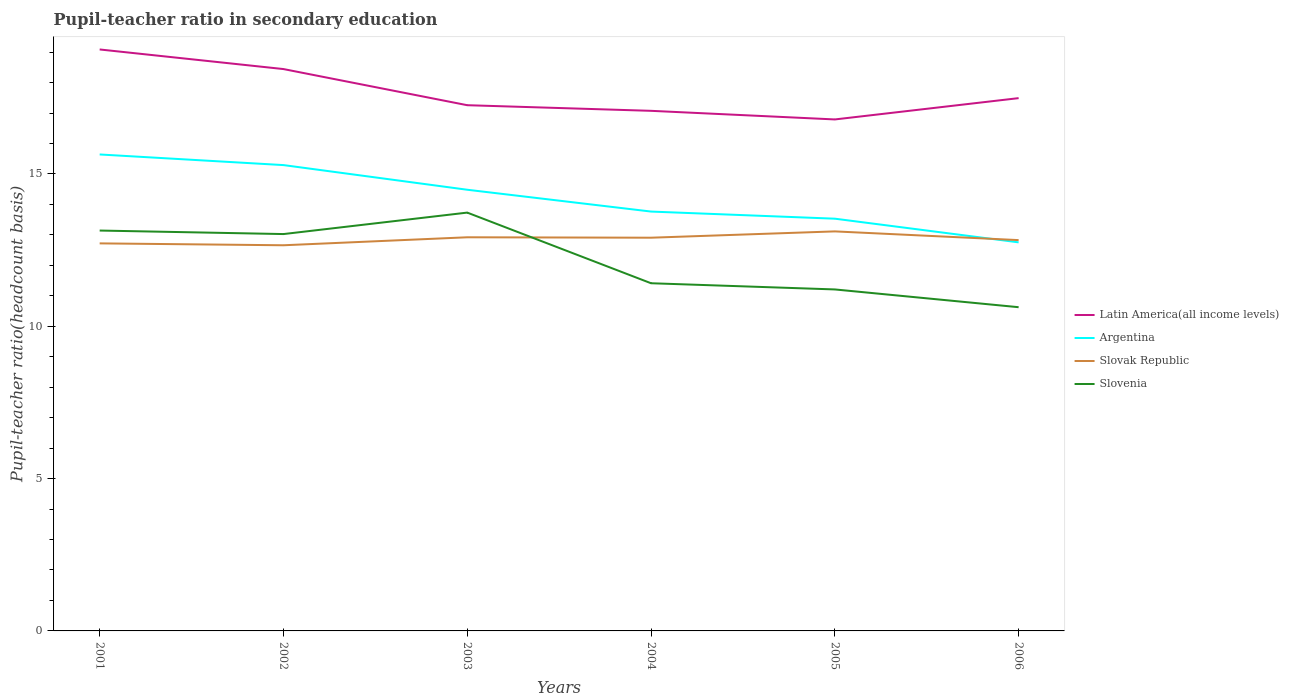Across all years, what is the maximum pupil-teacher ratio in secondary education in Argentina?
Your response must be concise. 12.76. What is the total pupil-teacher ratio in secondary education in Slovak Republic in the graph?
Keep it short and to the point. -0.26. What is the difference between the highest and the second highest pupil-teacher ratio in secondary education in Slovenia?
Provide a succinct answer. 3.11. Is the pupil-teacher ratio in secondary education in Argentina strictly greater than the pupil-teacher ratio in secondary education in Slovak Republic over the years?
Your answer should be compact. No. How many years are there in the graph?
Provide a succinct answer. 6. What is the difference between two consecutive major ticks on the Y-axis?
Offer a very short reply. 5. Does the graph contain grids?
Your response must be concise. No. How many legend labels are there?
Give a very brief answer. 4. What is the title of the graph?
Give a very brief answer. Pupil-teacher ratio in secondary education. Does "Poland" appear as one of the legend labels in the graph?
Ensure brevity in your answer.  No. What is the label or title of the Y-axis?
Ensure brevity in your answer.  Pupil-teacher ratio(headcount basis). What is the Pupil-teacher ratio(headcount basis) in Latin America(all income levels) in 2001?
Your answer should be very brief. 19.09. What is the Pupil-teacher ratio(headcount basis) in Argentina in 2001?
Your answer should be very brief. 15.64. What is the Pupil-teacher ratio(headcount basis) of Slovak Republic in 2001?
Make the answer very short. 12.72. What is the Pupil-teacher ratio(headcount basis) of Slovenia in 2001?
Ensure brevity in your answer.  13.14. What is the Pupil-teacher ratio(headcount basis) of Latin America(all income levels) in 2002?
Provide a short and direct response. 18.44. What is the Pupil-teacher ratio(headcount basis) of Argentina in 2002?
Ensure brevity in your answer.  15.29. What is the Pupil-teacher ratio(headcount basis) in Slovak Republic in 2002?
Keep it short and to the point. 12.66. What is the Pupil-teacher ratio(headcount basis) of Slovenia in 2002?
Offer a terse response. 13.03. What is the Pupil-teacher ratio(headcount basis) in Latin America(all income levels) in 2003?
Your response must be concise. 17.26. What is the Pupil-teacher ratio(headcount basis) in Argentina in 2003?
Your answer should be compact. 14.48. What is the Pupil-teacher ratio(headcount basis) in Slovak Republic in 2003?
Provide a short and direct response. 12.92. What is the Pupil-teacher ratio(headcount basis) of Slovenia in 2003?
Your answer should be compact. 13.73. What is the Pupil-teacher ratio(headcount basis) in Latin America(all income levels) in 2004?
Provide a succinct answer. 17.07. What is the Pupil-teacher ratio(headcount basis) of Argentina in 2004?
Your answer should be compact. 13.77. What is the Pupil-teacher ratio(headcount basis) in Slovak Republic in 2004?
Offer a very short reply. 12.91. What is the Pupil-teacher ratio(headcount basis) of Slovenia in 2004?
Offer a very short reply. 11.41. What is the Pupil-teacher ratio(headcount basis) in Latin America(all income levels) in 2005?
Make the answer very short. 16.79. What is the Pupil-teacher ratio(headcount basis) in Argentina in 2005?
Your answer should be very brief. 13.53. What is the Pupil-teacher ratio(headcount basis) of Slovak Republic in 2005?
Provide a short and direct response. 13.12. What is the Pupil-teacher ratio(headcount basis) of Slovenia in 2005?
Your answer should be compact. 11.21. What is the Pupil-teacher ratio(headcount basis) of Latin America(all income levels) in 2006?
Give a very brief answer. 17.49. What is the Pupil-teacher ratio(headcount basis) in Argentina in 2006?
Provide a short and direct response. 12.76. What is the Pupil-teacher ratio(headcount basis) in Slovak Republic in 2006?
Ensure brevity in your answer.  12.83. What is the Pupil-teacher ratio(headcount basis) of Slovenia in 2006?
Ensure brevity in your answer.  10.63. Across all years, what is the maximum Pupil-teacher ratio(headcount basis) in Latin America(all income levels)?
Your answer should be compact. 19.09. Across all years, what is the maximum Pupil-teacher ratio(headcount basis) in Argentina?
Provide a short and direct response. 15.64. Across all years, what is the maximum Pupil-teacher ratio(headcount basis) in Slovak Republic?
Your response must be concise. 13.12. Across all years, what is the maximum Pupil-teacher ratio(headcount basis) in Slovenia?
Your answer should be compact. 13.73. Across all years, what is the minimum Pupil-teacher ratio(headcount basis) in Latin America(all income levels)?
Your response must be concise. 16.79. Across all years, what is the minimum Pupil-teacher ratio(headcount basis) of Argentina?
Offer a terse response. 12.76. Across all years, what is the minimum Pupil-teacher ratio(headcount basis) in Slovak Republic?
Your answer should be compact. 12.66. Across all years, what is the minimum Pupil-teacher ratio(headcount basis) in Slovenia?
Ensure brevity in your answer.  10.63. What is the total Pupil-teacher ratio(headcount basis) in Latin America(all income levels) in the graph?
Provide a short and direct response. 106.14. What is the total Pupil-teacher ratio(headcount basis) in Argentina in the graph?
Ensure brevity in your answer.  85.47. What is the total Pupil-teacher ratio(headcount basis) in Slovak Republic in the graph?
Give a very brief answer. 77.16. What is the total Pupil-teacher ratio(headcount basis) of Slovenia in the graph?
Make the answer very short. 73.15. What is the difference between the Pupil-teacher ratio(headcount basis) in Latin America(all income levels) in 2001 and that in 2002?
Your answer should be compact. 0.64. What is the difference between the Pupil-teacher ratio(headcount basis) of Argentina in 2001 and that in 2002?
Provide a succinct answer. 0.35. What is the difference between the Pupil-teacher ratio(headcount basis) in Slovak Republic in 2001 and that in 2002?
Offer a very short reply. 0.06. What is the difference between the Pupil-teacher ratio(headcount basis) in Slovenia in 2001 and that in 2002?
Offer a terse response. 0.12. What is the difference between the Pupil-teacher ratio(headcount basis) of Latin America(all income levels) in 2001 and that in 2003?
Keep it short and to the point. 1.83. What is the difference between the Pupil-teacher ratio(headcount basis) of Argentina in 2001 and that in 2003?
Keep it short and to the point. 1.16. What is the difference between the Pupil-teacher ratio(headcount basis) of Slovak Republic in 2001 and that in 2003?
Ensure brevity in your answer.  -0.2. What is the difference between the Pupil-teacher ratio(headcount basis) of Slovenia in 2001 and that in 2003?
Offer a very short reply. -0.59. What is the difference between the Pupil-teacher ratio(headcount basis) of Latin America(all income levels) in 2001 and that in 2004?
Provide a succinct answer. 2.01. What is the difference between the Pupil-teacher ratio(headcount basis) of Argentina in 2001 and that in 2004?
Provide a short and direct response. 1.87. What is the difference between the Pupil-teacher ratio(headcount basis) in Slovak Republic in 2001 and that in 2004?
Provide a succinct answer. -0.19. What is the difference between the Pupil-teacher ratio(headcount basis) of Slovenia in 2001 and that in 2004?
Offer a terse response. 1.73. What is the difference between the Pupil-teacher ratio(headcount basis) in Latin America(all income levels) in 2001 and that in 2005?
Your answer should be very brief. 2.3. What is the difference between the Pupil-teacher ratio(headcount basis) of Argentina in 2001 and that in 2005?
Provide a succinct answer. 2.11. What is the difference between the Pupil-teacher ratio(headcount basis) in Slovak Republic in 2001 and that in 2005?
Your answer should be very brief. -0.39. What is the difference between the Pupil-teacher ratio(headcount basis) of Slovenia in 2001 and that in 2005?
Your answer should be compact. 1.93. What is the difference between the Pupil-teacher ratio(headcount basis) in Latin America(all income levels) in 2001 and that in 2006?
Provide a succinct answer. 1.6. What is the difference between the Pupil-teacher ratio(headcount basis) of Argentina in 2001 and that in 2006?
Provide a short and direct response. 2.88. What is the difference between the Pupil-teacher ratio(headcount basis) in Slovak Republic in 2001 and that in 2006?
Your response must be concise. -0.11. What is the difference between the Pupil-teacher ratio(headcount basis) in Slovenia in 2001 and that in 2006?
Provide a short and direct response. 2.52. What is the difference between the Pupil-teacher ratio(headcount basis) of Latin America(all income levels) in 2002 and that in 2003?
Provide a succinct answer. 1.19. What is the difference between the Pupil-teacher ratio(headcount basis) in Argentina in 2002 and that in 2003?
Offer a terse response. 0.81. What is the difference between the Pupil-teacher ratio(headcount basis) of Slovak Republic in 2002 and that in 2003?
Your response must be concise. -0.26. What is the difference between the Pupil-teacher ratio(headcount basis) in Slovenia in 2002 and that in 2003?
Provide a succinct answer. -0.7. What is the difference between the Pupil-teacher ratio(headcount basis) of Latin America(all income levels) in 2002 and that in 2004?
Your answer should be very brief. 1.37. What is the difference between the Pupil-teacher ratio(headcount basis) of Argentina in 2002 and that in 2004?
Your answer should be compact. 1.53. What is the difference between the Pupil-teacher ratio(headcount basis) of Slovak Republic in 2002 and that in 2004?
Provide a succinct answer. -0.25. What is the difference between the Pupil-teacher ratio(headcount basis) in Slovenia in 2002 and that in 2004?
Provide a short and direct response. 1.61. What is the difference between the Pupil-teacher ratio(headcount basis) of Latin America(all income levels) in 2002 and that in 2005?
Provide a succinct answer. 1.65. What is the difference between the Pupil-teacher ratio(headcount basis) in Argentina in 2002 and that in 2005?
Ensure brevity in your answer.  1.76. What is the difference between the Pupil-teacher ratio(headcount basis) of Slovak Republic in 2002 and that in 2005?
Offer a very short reply. -0.46. What is the difference between the Pupil-teacher ratio(headcount basis) in Slovenia in 2002 and that in 2005?
Provide a short and direct response. 1.82. What is the difference between the Pupil-teacher ratio(headcount basis) in Latin America(all income levels) in 2002 and that in 2006?
Your answer should be compact. 0.95. What is the difference between the Pupil-teacher ratio(headcount basis) in Argentina in 2002 and that in 2006?
Your response must be concise. 2.54. What is the difference between the Pupil-teacher ratio(headcount basis) in Slovak Republic in 2002 and that in 2006?
Offer a terse response. -0.17. What is the difference between the Pupil-teacher ratio(headcount basis) in Slovenia in 2002 and that in 2006?
Your answer should be very brief. 2.4. What is the difference between the Pupil-teacher ratio(headcount basis) of Latin America(all income levels) in 2003 and that in 2004?
Offer a very short reply. 0.18. What is the difference between the Pupil-teacher ratio(headcount basis) in Argentina in 2003 and that in 2004?
Make the answer very short. 0.72. What is the difference between the Pupil-teacher ratio(headcount basis) of Slovak Republic in 2003 and that in 2004?
Your answer should be compact. 0.01. What is the difference between the Pupil-teacher ratio(headcount basis) of Slovenia in 2003 and that in 2004?
Provide a short and direct response. 2.32. What is the difference between the Pupil-teacher ratio(headcount basis) of Latin America(all income levels) in 2003 and that in 2005?
Your answer should be compact. 0.47. What is the difference between the Pupil-teacher ratio(headcount basis) of Argentina in 2003 and that in 2005?
Keep it short and to the point. 0.95. What is the difference between the Pupil-teacher ratio(headcount basis) of Slovak Republic in 2003 and that in 2005?
Your answer should be very brief. -0.19. What is the difference between the Pupil-teacher ratio(headcount basis) of Slovenia in 2003 and that in 2005?
Ensure brevity in your answer.  2.52. What is the difference between the Pupil-teacher ratio(headcount basis) in Latin America(all income levels) in 2003 and that in 2006?
Keep it short and to the point. -0.23. What is the difference between the Pupil-teacher ratio(headcount basis) in Argentina in 2003 and that in 2006?
Make the answer very short. 1.73. What is the difference between the Pupil-teacher ratio(headcount basis) of Slovak Republic in 2003 and that in 2006?
Make the answer very short. 0.09. What is the difference between the Pupil-teacher ratio(headcount basis) in Slovenia in 2003 and that in 2006?
Offer a very short reply. 3.11. What is the difference between the Pupil-teacher ratio(headcount basis) of Latin America(all income levels) in 2004 and that in 2005?
Provide a succinct answer. 0.28. What is the difference between the Pupil-teacher ratio(headcount basis) of Argentina in 2004 and that in 2005?
Your response must be concise. 0.23. What is the difference between the Pupil-teacher ratio(headcount basis) in Slovak Republic in 2004 and that in 2005?
Ensure brevity in your answer.  -0.21. What is the difference between the Pupil-teacher ratio(headcount basis) in Slovenia in 2004 and that in 2005?
Your response must be concise. 0.2. What is the difference between the Pupil-teacher ratio(headcount basis) of Latin America(all income levels) in 2004 and that in 2006?
Keep it short and to the point. -0.42. What is the difference between the Pupil-teacher ratio(headcount basis) of Argentina in 2004 and that in 2006?
Offer a terse response. 1.01. What is the difference between the Pupil-teacher ratio(headcount basis) of Slovak Republic in 2004 and that in 2006?
Provide a short and direct response. 0.08. What is the difference between the Pupil-teacher ratio(headcount basis) in Slovenia in 2004 and that in 2006?
Your response must be concise. 0.79. What is the difference between the Pupil-teacher ratio(headcount basis) of Latin America(all income levels) in 2005 and that in 2006?
Provide a short and direct response. -0.7. What is the difference between the Pupil-teacher ratio(headcount basis) in Argentina in 2005 and that in 2006?
Give a very brief answer. 0.78. What is the difference between the Pupil-teacher ratio(headcount basis) in Slovak Republic in 2005 and that in 2006?
Provide a short and direct response. 0.29. What is the difference between the Pupil-teacher ratio(headcount basis) of Slovenia in 2005 and that in 2006?
Give a very brief answer. 0.58. What is the difference between the Pupil-teacher ratio(headcount basis) of Latin America(all income levels) in 2001 and the Pupil-teacher ratio(headcount basis) of Argentina in 2002?
Keep it short and to the point. 3.8. What is the difference between the Pupil-teacher ratio(headcount basis) of Latin America(all income levels) in 2001 and the Pupil-teacher ratio(headcount basis) of Slovak Republic in 2002?
Offer a very short reply. 6.43. What is the difference between the Pupil-teacher ratio(headcount basis) of Latin America(all income levels) in 2001 and the Pupil-teacher ratio(headcount basis) of Slovenia in 2002?
Keep it short and to the point. 6.06. What is the difference between the Pupil-teacher ratio(headcount basis) of Argentina in 2001 and the Pupil-teacher ratio(headcount basis) of Slovak Republic in 2002?
Your answer should be compact. 2.98. What is the difference between the Pupil-teacher ratio(headcount basis) of Argentina in 2001 and the Pupil-teacher ratio(headcount basis) of Slovenia in 2002?
Offer a very short reply. 2.61. What is the difference between the Pupil-teacher ratio(headcount basis) in Slovak Republic in 2001 and the Pupil-teacher ratio(headcount basis) in Slovenia in 2002?
Keep it short and to the point. -0.31. What is the difference between the Pupil-teacher ratio(headcount basis) in Latin America(all income levels) in 2001 and the Pupil-teacher ratio(headcount basis) in Argentina in 2003?
Provide a short and direct response. 4.6. What is the difference between the Pupil-teacher ratio(headcount basis) of Latin America(all income levels) in 2001 and the Pupil-teacher ratio(headcount basis) of Slovak Republic in 2003?
Your answer should be very brief. 6.17. What is the difference between the Pupil-teacher ratio(headcount basis) in Latin America(all income levels) in 2001 and the Pupil-teacher ratio(headcount basis) in Slovenia in 2003?
Give a very brief answer. 5.36. What is the difference between the Pupil-teacher ratio(headcount basis) in Argentina in 2001 and the Pupil-teacher ratio(headcount basis) in Slovak Republic in 2003?
Ensure brevity in your answer.  2.72. What is the difference between the Pupil-teacher ratio(headcount basis) of Argentina in 2001 and the Pupil-teacher ratio(headcount basis) of Slovenia in 2003?
Give a very brief answer. 1.91. What is the difference between the Pupil-teacher ratio(headcount basis) of Slovak Republic in 2001 and the Pupil-teacher ratio(headcount basis) of Slovenia in 2003?
Give a very brief answer. -1.01. What is the difference between the Pupil-teacher ratio(headcount basis) in Latin America(all income levels) in 2001 and the Pupil-teacher ratio(headcount basis) in Argentina in 2004?
Your answer should be compact. 5.32. What is the difference between the Pupil-teacher ratio(headcount basis) in Latin America(all income levels) in 2001 and the Pupil-teacher ratio(headcount basis) in Slovak Republic in 2004?
Ensure brevity in your answer.  6.18. What is the difference between the Pupil-teacher ratio(headcount basis) of Latin America(all income levels) in 2001 and the Pupil-teacher ratio(headcount basis) of Slovenia in 2004?
Keep it short and to the point. 7.67. What is the difference between the Pupil-teacher ratio(headcount basis) of Argentina in 2001 and the Pupil-teacher ratio(headcount basis) of Slovak Republic in 2004?
Make the answer very short. 2.73. What is the difference between the Pupil-teacher ratio(headcount basis) of Argentina in 2001 and the Pupil-teacher ratio(headcount basis) of Slovenia in 2004?
Make the answer very short. 4.23. What is the difference between the Pupil-teacher ratio(headcount basis) in Slovak Republic in 2001 and the Pupil-teacher ratio(headcount basis) in Slovenia in 2004?
Ensure brevity in your answer.  1.31. What is the difference between the Pupil-teacher ratio(headcount basis) of Latin America(all income levels) in 2001 and the Pupil-teacher ratio(headcount basis) of Argentina in 2005?
Provide a succinct answer. 5.55. What is the difference between the Pupil-teacher ratio(headcount basis) of Latin America(all income levels) in 2001 and the Pupil-teacher ratio(headcount basis) of Slovak Republic in 2005?
Provide a short and direct response. 5.97. What is the difference between the Pupil-teacher ratio(headcount basis) of Latin America(all income levels) in 2001 and the Pupil-teacher ratio(headcount basis) of Slovenia in 2005?
Keep it short and to the point. 7.88. What is the difference between the Pupil-teacher ratio(headcount basis) in Argentina in 2001 and the Pupil-teacher ratio(headcount basis) in Slovak Republic in 2005?
Your answer should be compact. 2.53. What is the difference between the Pupil-teacher ratio(headcount basis) in Argentina in 2001 and the Pupil-teacher ratio(headcount basis) in Slovenia in 2005?
Keep it short and to the point. 4.43. What is the difference between the Pupil-teacher ratio(headcount basis) of Slovak Republic in 2001 and the Pupil-teacher ratio(headcount basis) of Slovenia in 2005?
Provide a short and direct response. 1.51. What is the difference between the Pupil-teacher ratio(headcount basis) of Latin America(all income levels) in 2001 and the Pupil-teacher ratio(headcount basis) of Argentina in 2006?
Your answer should be compact. 6.33. What is the difference between the Pupil-teacher ratio(headcount basis) in Latin America(all income levels) in 2001 and the Pupil-teacher ratio(headcount basis) in Slovak Republic in 2006?
Make the answer very short. 6.26. What is the difference between the Pupil-teacher ratio(headcount basis) of Latin America(all income levels) in 2001 and the Pupil-teacher ratio(headcount basis) of Slovenia in 2006?
Your response must be concise. 8.46. What is the difference between the Pupil-teacher ratio(headcount basis) in Argentina in 2001 and the Pupil-teacher ratio(headcount basis) in Slovak Republic in 2006?
Provide a short and direct response. 2.81. What is the difference between the Pupil-teacher ratio(headcount basis) of Argentina in 2001 and the Pupil-teacher ratio(headcount basis) of Slovenia in 2006?
Offer a very short reply. 5.01. What is the difference between the Pupil-teacher ratio(headcount basis) of Slovak Republic in 2001 and the Pupil-teacher ratio(headcount basis) of Slovenia in 2006?
Ensure brevity in your answer.  2.1. What is the difference between the Pupil-teacher ratio(headcount basis) in Latin America(all income levels) in 2002 and the Pupil-teacher ratio(headcount basis) in Argentina in 2003?
Your response must be concise. 3.96. What is the difference between the Pupil-teacher ratio(headcount basis) of Latin America(all income levels) in 2002 and the Pupil-teacher ratio(headcount basis) of Slovak Republic in 2003?
Offer a terse response. 5.52. What is the difference between the Pupil-teacher ratio(headcount basis) in Latin America(all income levels) in 2002 and the Pupil-teacher ratio(headcount basis) in Slovenia in 2003?
Your answer should be very brief. 4.71. What is the difference between the Pupil-teacher ratio(headcount basis) of Argentina in 2002 and the Pupil-teacher ratio(headcount basis) of Slovak Republic in 2003?
Ensure brevity in your answer.  2.37. What is the difference between the Pupil-teacher ratio(headcount basis) of Argentina in 2002 and the Pupil-teacher ratio(headcount basis) of Slovenia in 2003?
Make the answer very short. 1.56. What is the difference between the Pupil-teacher ratio(headcount basis) of Slovak Republic in 2002 and the Pupil-teacher ratio(headcount basis) of Slovenia in 2003?
Provide a succinct answer. -1.07. What is the difference between the Pupil-teacher ratio(headcount basis) of Latin America(all income levels) in 2002 and the Pupil-teacher ratio(headcount basis) of Argentina in 2004?
Your answer should be compact. 4.68. What is the difference between the Pupil-teacher ratio(headcount basis) in Latin America(all income levels) in 2002 and the Pupil-teacher ratio(headcount basis) in Slovak Republic in 2004?
Provide a short and direct response. 5.54. What is the difference between the Pupil-teacher ratio(headcount basis) in Latin America(all income levels) in 2002 and the Pupil-teacher ratio(headcount basis) in Slovenia in 2004?
Provide a short and direct response. 7.03. What is the difference between the Pupil-teacher ratio(headcount basis) in Argentina in 2002 and the Pupil-teacher ratio(headcount basis) in Slovak Republic in 2004?
Provide a succinct answer. 2.38. What is the difference between the Pupil-teacher ratio(headcount basis) of Argentina in 2002 and the Pupil-teacher ratio(headcount basis) of Slovenia in 2004?
Make the answer very short. 3.88. What is the difference between the Pupil-teacher ratio(headcount basis) of Slovak Republic in 2002 and the Pupil-teacher ratio(headcount basis) of Slovenia in 2004?
Provide a succinct answer. 1.25. What is the difference between the Pupil-teacher ratio(headcount basis) of Latin America(all income levels) in 2002 and the Pupil-teacher ratio(headcount basis) of Argentina in 2005?
Your response must be concise. 4.91. What is the difference between the Pupil-teacher ratio(headcount basis) of Latin America(all income levels) in 2002 and the Pupil-teacher ratio(headcount basis) of Slovak Republic in 2005?
Your answer should be compact. 5.33. What is the difference between the Pupil-teacher ratio(headcount basis) in Latin America(all income levels) in 2002 and the Pupil-teacher ratio(headcount basis) in Slovenia in 2005?
Your response must be concise. 7.23. What is the difference between the Pupil-teacher ratio(headcount basis) of Argentina in 2002 and the Pupil-teacher ratio(headcount basis) of Slovak Republic in 2005?
Your response must be concise. 2.18. What is the difference between the Pupil-teacher ratio(headcount basis) in Argentina in 2002 and the Pupil-teacher ratio(headcount basis) in Slovenia in 2005?
Offer a terse response. 4.08. What is the difference between the Pupil-teacher ratio(headcount basis) in Slovak Republic in 2002 and the Pupil-teacher ratio(headcount basis) in Slovenia in 2005?
Make the answer very short. 1.45. What is the difference between the Pupil-teacher ratio(headcount basis) in Latin America(all income levels) in 2002 and the Pupil-teacher ratio(headcount basis) in Argentina in 2006?
Provide a succinct answer. 5.69. What is the difference between the Pupil-teacher ratio(headcount basis) in Latin America(all income levels) in 2002 and the Pupil-teacher ratio(headcount basis) in Slovak Republic in 2006?
Keep it short and to the point. 5.62. What is the difference between the Pupil-teacher ratio(headcount basis) of Latin America(all income levels) in 2002 and the Pupil-teacher ratio(headcount basis) of Slovenia in 2006?
Keep it short and to the point. 7.82. What is the difference between the Pupil-teacher ratio(headcount basis) of Argentina in 2002 and the Pupil-teacher ratio(headcount basis) of Slovak Republic in 2006?
Your response must be concise. 2.46. What is the difference between the Pupil-teacher ratio(headcount basis) of Argentina in 2002 and the Pupil-teacher ratio(headcount basis) of Slovenia in 2006?
Offer a very short reply. 4.67. What is the difference between the Pupil-teacher ratio(headcount basis) of Slovak Republic in 2002 and the Pupil-teacher ratio(headcount basis) of Slovenia in 2006?
Provide a short and direct response. 2.03. What is the difference between the Pupil-teacher ratio(headcount basis) in Latin America(all income levels) in 2003 and the Pupil-teacher ratio(headcount basis) in Argentina in 2004?
Provide a succinct answer. 3.49. What is the difference between the Pupil-teacher ratio(headcount basis) of Latin America(all income levels) in 2003 and the Pupil-teacher ratio(headcount basis) of Slovak Republic in 2004?
Your answer should be compact. 4.35. What is the difference between the Pupil-teacher ratio(headcount basis) of Latin America(all income levels) in 2003 and the Pupil-teacher ratio(headcount basis) of Slovenia in 2004?
Give a very brief answer. 5.84. What is the difference between the Pupil-teacher ratio(headcount basis) of Argentina in 2003 and the Pupil-teacher ratio(headcount basis) of Slovak Republic in 2004?
Give a very brief answer. 1.57. What is the difference between the Pupil-teacher ratio(headcount basis) in Argentina in 2003 and the Pupil-teacher ratio(headcount basis) in Slovenia in 2004?
Keep it short and to the point. 3.07. What is the difference between the Pupil-teacher ratio(headcount basis) in Slovak Republic in 2003 and the Pupil-teacher ratio(headcount basis) in Slovenia in 2004?
Your answer should be very brief. 1.51. What is the difference between the Pupil-teacher ratio(headcount basis) in Latin America(all income levels) in 2003 and the Pupil-teacher ratio(headcount basis) in Argentina in 2005?
Keep it short and to the point. 3.73. What is the difference between the Pupil-teacher ratio(headcount basis) of Latin America(all income levels) in 2003 and the Pupil-teacher ratio(headcount basis) of Slovak Republic in 2005?
Provide a short and direct response. 4.14. What is the difference between the Pupil-teacher ratio(headcount basis) of Latin America(all income levels) in 2003 and the Pupil-teacher ratio(headcount basis) of Slovenia in 2005?
Provide a short and direct response. 6.05. What is the difference between the Pupil-teacher ratio(headcount basis) of Argentina in 2003 and the Pupil-teacher ratio(headcount basis) of Slovak Republic in 2005?
Your answer should be very brief. 1.37. What is the difference between the Pupil-teacher ratio(headcount basis) of Argentina in 2003 and the Pupil-teacher ratio(headcount basis) of Slovenia in 2005?
Offer a terse response. 3.27. What is the difference between the Pupil-teacher ratio(headcount basis) of Slovak Republic in 2003 and the Pupil-teacher ratio(headcount basis) of Slovenia in 2005?
Your answer should be very brief. 1.71. What is the difference between the Pupil-teacher ratio(headcount basis) of Latin America(all income levels) in 2003 and the Pupil-teacher ratio(headcount basis) of Argentina in 2006?
Offer a terse response. 4.5. What is the difference between the Pupil-teacher ratio(headcount basis) in Latin America(all income levels) in 2003 and the Pupil-teacher ratio(headcount basis) in Slovak Republic in 2006?
Your answer should be very brief. 4.43. What is the difference between the Pupil-teacher ratio(headcount basis) in Latin America(all income levels) in 2003 and the Pupil-teacher ratio(headcount basis) in Slovenia in 2006?
Ensure brevity in your answer.  6.63. What is the difference between the Pupil-teacher ratio(headcount basis) of Argentina in 2003 and the Pupil-teacher ratio(headcount basis) of Slovak Republic in 2006?
Keep it short and to the point. 1.65. What is the difference between the Pupil-teacher ratio(headcount basis) in Argentina in 2003 and the Pupil-teacher ratio(headcount basis) in Slovenia in 2006?
Provide a succinct answer. 3.86. What is the difference between the Pupil-teacher ratio(headcount basis) of Slovak Republic in 2003 and the Pupil-teacher ratio(headcount basis) of Slovenia in 2006?
Your response must be concise. 2.3. What is the difference between the Pupil-teacher ratio(headcount basis) in Latin America(all income levels) in 2004 and the Pupil-teacher ratio(headcount basis) in Argentina in 2005?
Ensure brevity in your answer.  3.54. What is the difference between the Pupil-teacher ratio(headcount basis) in Latin America(all income levels) in 2004 and the Pupil-teacher ratio(headcount basis) in Slovak Republic in 2005?
Give a very brief answer. 3.96. What is the difference between the Pupil-teacher ratio(headcount basis) of Latin America(all income levels) in 2004 and the Pupil-teacher ratio(headcount basis) of Slovenia in 2005?
Offer a very short reply. 5.86. What is the difference between the Pupil-teacher ratio(headcount basis) in Argentina in 2004 and the Pupil-teacher ratio(headcount basis) in Slovak Republic in 2005?
Give a very brief answer. 0.65. What is the difference between the Pupil-teacher ratio(headcount basis) in Argentina in 2004 and the Pupil-teacher ratio(headcount basis) in Slovenia in 2005?
Provide a short and direct response. 2.56. What is the difference between the Pupil-teacher ratio(headcount basis) of Slovak Republic in 2004 and the Pupil-teacher ratio(headcount basis) of Slovenia in 2005?
Your answer should be compact. 1.7. What is the difference between the Pupil-teacher ratio(headcount basis) of Latin America(all income levels) in 2004 and the Pupil-teacher ratio(headcount basis) of Argentina in 2006?
Your answer should be compact. 4.32. What is the difference between the Pupil-teacher ratio(headcount basis) of Latin America(all income levels) in 2004 and the Pupil-teacher ratio(headcount basis) of Slovak Republic in 2006?
Make the answer very short. 4.24. What is the difference between the Pupil-teacher ratio(headcount basis) in Latin America(all income levels) in 2004 and the Pupil-teacher ratio(headcount basis) in Slovenia in 2006?
Provide a short and direct response. 6.45. What is the difference between the Pupil-teacher ratio(headcount basis) of Argentina in 2004 and the Pupil-teacher ratio(headcount basis) of Slovak Republic in 2006?
Provide a short and direct response. 0.94. What is the difference between the Pupil-teacher ratio(headcount basis) in Argentina in 2004 and the Pupil-teacher ratio(headcount basis) in Slovenia in 2006?
Your answer should be very brief. 3.14. What is the difference between the Pupil-teacher ratio(headcount basis) in Slovak Republic in 2004 and the Pupil-teacher ratio(headcount basis) in Slovenia in 2006?
Keep it short and to the point. 2.28. What is the difference between the Pupil-teacher ratio(headcount basis) in Latin America(all income levels) in 2005 and the Pupil-teacher ratio(headcount basis) in Argentina in 2006?
Your response must be concise. 4.03. What is the difference between the Pupil-teacher ratio(headcount basis) in Latin America(all income levels) in 2005 and the Pupil-teacher ratio(headcount basis) in Slovak Republic in 2006?
Give a very brief answer. 3.96. What is the difference between the Pupil-teacher ratio(headcount basis) of Latin America(all income levels) in 2005 and the Pupil-teacher ratio(headcount basis) of Slovenia in 2006?
Make the answer very short. 6.16. What is the difference between the Pupil-teacher ratio(headcount basis) in Argentina in 2005 and the Pupil-teacher ratio(headcount basis) in Slovak Republic in 2006?
Ensure brevity in your answer.  0.7. What is the difference between the Pupil-teacher ratio(headcount basis) in Argentina in 2005 and the Pupil-teacher ratio(headcount basis) in Slovenia in 2006?
Your response must be concise. 2.91. What is the difference between the Pupil-teacher ratio(headcount basis) of Slovak Republic in 2005 and the Pupil-teacher ratio(headcount basis) of Slovenia in 2006?
Your response must be concise. 2.49. What is the average Pupil-teacher ratio(headcount basis) in Latin America(all income levels) per year?
Your response must be concise. 17.69. What is the average Pupil-teacher ratio(headcount basis) of Argentina per year?
Your response must be concise. 14.24. What is the average Pupil-teacher ratio(headcount basis) in Slovak Republic per year?
Offer a terse response. 12.86. What is the average Pupil-teacher ratio(headcount basis) in Slovenia per year?
Ensure brevity in your answer.  12.19. In the year 2001, what is the difference between the Pupil-teacher ratio(headcount basis) of Latin America(all income levels) and Pupil-teacher ratio(headcount basis) of Argentina?
Ensure brevity in your answer.  3.45. In the year 2001, what is the difference between the Pupil-teacher ratio(headcount basis) of Latin America(all income levels) and Pupil-teacher ratio(headcount basis) of Slovak Republic?
Give a very brief answer. 6.37. In the year 2001, what is the difference between the Pupil-teacher ratio(headcount basis) of Latin America(all income levels) and Pupil-teacher ratio(headcount basis) of Slovenia?
Ensure brevity in your answer.  5.94. In the year 2001, what is the difference between the Pupil-teacher ratio(headcount basis) of Argentina and Pupil-teacher ratio(headcount basis) of Slovak Republic?
Offer a terse response. 2.92. In the year 2001, what is the difference between the Pupil-teacher ratio(headcount basis) in Argentina and Pupil-teacher ratio(headcount basis) in Slovenia?
Your response must be concise. 2.5. In the year 2001, what is the difference between the Pupil-teacher ratio(headcount basis) of Slovak Republic and Pupil-teacher ratio(headcount basis) of Slovenia?
Make the answer very short. -0.42. In the year 2002, what is the difference between the Pupil-teacher ratio(headcount basis) in Latin America(all income levels) and Pupil-teacher ratio(headcount basis) in Argentina?
Your response must be concise. 3.15. In the year 2002, what is the difference between the Pupil-teacher ratio(headcount basis) in Latin America(all income levels) and Pupil-teacher ratio(headcount basis) in Slovak Republic?
Give a very brief answer. 5.78. In the year 2002, what is the difference between the Pupil-teacher ratio(headcount basis) in Latin America(all income levels) and Pupil-teacher ratio(headcount basis) in Slovenia?
Offer a terse response. 5.42. In the year 2002, what is the difference between the Pupil-teacher ratio(headcount basis) of Argentina and Pupil-teacher ratio(headcount basis) of Slovak Republic?
Offer a terse response. 2.63. In the year 2002, what is the difference between the Pupil-teacher ratio(headcount basis) of Argentina and Pupil-teacher ratio(headcount basis) of Slovenia?
Provide a short and direct response. 2.26. In the year 2002, what is the difference between the Pupil-teacher ratio(headcount basis) in Slovak Republic and Pupil-teacher ratio(headcount basis) in Slovenia?
Your answer should be very brief. -0.37. In the year 2003, what is the difference between the Pupil-teacher ratio(headcount basis) in Latin America(all income levels) and Pupil-teacher ratio(headcount basis) in Argentina?
Provide a short and direct response. 2.77. In the year 2003, what is the difference between the Pupil-teacher ratio(headcount basis) of Latin America(all income levels) and Pupil-teacher ratio(headcount basis) of Slovak Republic?
Your response must be concise. 4.34. In the year 2003, what is the difference between the Pupil-teacher ratio(headcount basis) in Latin America(all income levels) and Pupil-teacher ratio(headcount basis) in Slovenia?
Provide a short and direct response. 3.53. In the year 2003, what is the difference between the Pupil-teacher ratio(headcount basis) in Argentina and Pupil-teacher ratio(headcount basis) in Slovak Republic?
Offer a terse response. 1.56. In the year 2003, what is the difference between the Pupil-teacher ratio(headcount basis) in Argentina and Pupil-teacher ratio(headcount basis) in Slovenia?
Give a very brief answer. 0.75. In the year 2003, what is the difference between the Pupil-teacher ratio(headcount basis) of Slovak Republic and Pupil-teacher ratio(headcount basis) of Slovenia?
Keep it short and to the point. -0.81. In the year 2004, what is the difference between the Pupil-teacher ratio(headcount basis) in Latin America(all income levels) and Pupil-teacher ratio(headcount basis) in Argentina?
Keep it short and to the point. 3.31. In the year 2004, what is the difference between the Pupil-teacher ratio(headcount basis) in Latin America(all income levels) and Pupil-teacher ratio(headcount basis) in Slovak Republic?
Your answer should be very brief. 4.16. In the year 2004, what is the difference between the Pupil-teacher ratio(headcount basis) of Latin America(all income levels) and Pupil-teacher ratio(headcount basis) of Slovenia?
Provide a succinct answer. 5.66. In the year 2004, what is the difference between the Pupil-teacher ratio(headcount basis) in Argentina and Pupil-teacher ratio(headcount basis) in Slovak Republic?
Give a very brief answer. 0.86. In the year 2004, what is the difference between the Pupil-teacher ratio(headcount basis) of Argentina and Pupil-teacher ratio(headcount basis) of Slovenia?
Give a very brief answer. 2.35. In the year 2004, what is the difference between the Pupil-teacher ratio(headcount basis) of Slovak Republic and Pupil-teacher ratio(headcount basis) of Slovenia?
Keep it short and to the point. 1.5. In the year 2005, what is the difference between the Pupil-teacher ratio(headcount basis) in Latin America(all income levels) and Pupil-teacher ratio(headcount basis) in Argentina?
Keep it short and to the point. 3.26. In the year 2005, what is the difference between the Pupil-teacher ratio(headcount basis) in Latin America(all income levels) and Pupil-teacher ratio(headcount basis) in Slovak Republic?
Ensure brevity in your answer.  3.68. In the year 2005, what is the difference between the Pupil-teacher ratio(headcount basis) of Latin America(all income levels) and Pupil-teacher ratio(headcount basis) of Slovenia?
Your answer should be very brief. 5.58. In the year 2005, what is the difference between the Pupil-teacher ratio(headcount basis) in Argentina and Pupil-teacher ratio(headcount basis) in Slovak Republic?
Your response must be concise. 0.42. In the year 2005, what is the difference between the Pupil-teacher ratio(headcount basis) in Argentina and Pupil-teacher ratio(headcount basis) in Slovenia?
Your response must be concise. 2.32. In the year 2005, what is the difference between the Pupil-teacher ratio(headcount basis) in Slovak Republic and Pupil-teacher ratio(headcount basis) in Slovenia?
Provide a short and direct response. 1.91. In the year 2006, what is the difference between the Pupil-teacher ratio(headcount basis) of Latin America(all income levels) and Pupil-teacher ratio(headcount basis) of Argentina?
Your response must be concise. 4.73. In the year 2006, what is the difference between the Pupil-teacher ratio(headcount basis) in Latin America(all income levels) and Pupil-teacher ratio(headcount basis) in Slovak Republic?
Your response must be concise. 4.66. In the year 2006, what is the difference between the Pupil-teacher ratio(headcount basis) in Latin America(all income levels) and Pupil-teacher ratio(headcount basis) in Slovenia?
Keep it short and to the point. 6.86. In the year 2006, what is the difference between the Pupil-teacher ratio(headcount basis) in Argentina and Pupil-teacher ratio(headcount basis) in Slovak Republic?
Ensure brevity in your answer.  -0.07. In the year 2006, what is the difference between the Pupil-teacher ratio(headcount basis) of Argentina and Pupil-teacher ratio(headcount basis) of Slovenia?
Your response must be concise. 2.13. In the year 2006, what is the difference between the Pupil-teacher ratio(headcount basis) in Slovak Republic and Pupil-teacher ratio(headcount basis) in Slovenia?
Keep it short and to the point. 2.2. What is the ratio of the Pupil-teacher ratio(headcount basis) of Latin America(all income levels) in 2001 to that in 2002?
Provide a short and direct response. 1.03. What is the ratio of the Pupil-teacher ratio(headcount basis) of Argentina in 2001 to that in 2002?
Keep it short and to the point. 1.02. What is the ratio of the Pupil-teacher ratio(headcount basis) of Slovak Republic in 2001 to that in 2002?
Your answer should be compact. 1. What is the ratio of the Pupil-teacher ratio(headcount basis) of Slovenia in 2001 to that in 2002?
Make the answer very short. 1.01. What is the ratio of the Pupil-teacher ratio(headcount basis) in Latin America(all income levels) in 2001 to that in 2003?
Ensure brevity in your answer.  1.11. What is the ratio of the Pupil-teacher ratio(headcount basis) of Argentina in 2001 to that in 2003?
Offer a terse response. 1.08. What is the ratio of the Pupil-teacher ratio(headcount basis) in Slovak Republic in 2001 to that in 2003?
Your response must be concise. 0.98. What is the ratio of the Pupil-teacher ratio(headcount basis) in Slovenia in 2001 to that in 2003?
Give a very brief answer. 0.96. What is the ratio of the Pupil-teacher ratio(headcount basis) in Latin America(all income levels) in 2001 to that in 2004?
Your response must be concise. 1.12. What is the ratio of the Pupil-teacher ratio(headcount basis) in Argentina in 2001 to that in 2004?
Provide a succinct answer. 1.14. What is the ratio of the Pupil-teacher ratio(headcount basis) in Slovak Republic in 2001 to that in 2004?
Your response must be concise. 0.99. What is the ratio of the Pupil-teacher ratio(headcount basis) in Slovenia in 2001 to that in 2004?
Your response must be concise. 1.15. What is the ratio of the Pupil-teacher ratio(headcount basis) of Latin America(all income levels) in 2001 to that in 2005?
Your answer should be compact. 1.14. What is the ratio of the Pupil-teacher ratio(headcount basis) of Argentina in 2001 to that in 2005?
Make the answer very short. 1.16. What is the ratio of the Pupil-teacher ratio(headcount basis) in Slovenia in 2001 to that in 2005?
Ensure brevity in your answer.  1.17. What is the ratio of the Pupil-teacher ratio(headcount basis) in Latin America(all income levels) in 2001 to that in 2006?
Give a very brief answer. 1.09. What is the ratio of the Pupil-teacher ratio(headcount basis) in Argentina in 2001 to that in 2006?
Your response must be concise. 1.23. What is the ratio of the Pupil-teacher ratio(headcount basis) in Slovenia in 2001 to that in 2006?
Offer a terse response. 1.24. What is the ratio of the Pupil-teacher ratio(headcount basis) of Latin America(all income levels) in 2002 to that in 2003?
Provide a succinct answer. 1.07. What is the ratio of the Pupil-teacher ratio(headcount basis) of Argentina in 2002 to that in 2003?
Your answer should be very brief. 1.06. What is the ratio of the Pupil-teacher ratio(headcount basis) in Slovak Republic in 2002 to that in 2003?
Give a very brief answer. 0.98. What is the ratio of the Pupil-teacher ratio(headcount basis) of Slovenia in 2002 to that in 2003?
Keep it short and to the point. 0.95. What is the ratio of the Pupil-teacher ratio(headcount basis) of Latin America(all income levels) in 2002 to that in 2004?
Ensure brevity in your answer.  1.08. What is the ratio of the Pupil-teacher ratio(headcount basis) of Argentina in 2002 to that in 2004?
Your response must be concise. 1.11. What is the ratio of the Pupil-teacher ratio(headcount basis) of Slovak Republic in 2002 to that in 2004?
Your response must be concise. 0.98. What is the ratio of the Pupil-teacher ratio(headcount basis) of Slovenia in 2002 to that in 2004?
Ensure brevity in your answer.  1.14. What is the ratio of the Pupil-teacher ratio(headcount basis) of Latin America(all income levels) in 2002 to that in 2005?
Provide a short and direct response. 1.1. What is the ratio of the Pupil-teacher ratio(headcount basis) of Argentina in 2002 to that in 2005?
Offer a terse response. 1.13. What is the ratio of the Pupil-teacher ratio(headcount basis) of Slovak Republic in 2002 to that in 2005?
Your response must be concise. 0.97. What is the ratio of the Pupil-teacher ratio(headcount basis) of Slovenia in 2002 to that in 2005?
Provide a succinct answer. 1.16. What is the ratio of the Pupil-teacher ratio(headcount basis) in Latin America(all income levels) in 2002 to that in 2006?
Your answer should be very brief. 1.05. What is the ratio of the Pupil-teacher ratio(headcount basis) of Argentina in 2002 to that in 2006?
Provide a short and direct response. 1.2. What is the ratio of the Pupil-teacher ratio(headcount basis) of Slovak Republic in 2002 to that in 2006?
Ensure brevity in your answer.  0.99. What is the ratio of the Pupil-teacher ratio(headcount basis) in Slovenia in 2002 to that in 2006?
Keep it short and to the point. 1.23. What is the ratio of the Pupil-teacher ratio(headcount basis) of Latin America(all income levels) in 2003 to that in 2004?
Ensure brevity in your answer.  1.01. What is the ratio of the Pupil-teacher ratio(headcount basis) in Argentina in 2003 to that in 2004?
Your answer should be very brief. 1.05. What is the ratio of the Pupil-teacher ratio(headcount basis) of Slovenia in 2003 to that in 2004?
Your answer should be very brief. 1.2. What is the ratio of the Pupil-teacher ratio(headcount basis) of Latin America(all income levels) in 2003 to that in 2005?
Ensure brevity in your answer.  1.03. What is the ratio of the Pupil-teacher ratio(headcount basis) in Argentina in 2003 to that in 2005?
Provide a short and direct response. 1.07. What is the ratio of the Pupil-teacher ratio(headcount basis) in Slovenia in 2003 to that in 2005?
Your response must be concise. 1.23. What is the ratio of the Pupil-teacher ratio(headcount basis) of Latin America(all income levels) in 2003 to that in 2006?
Your answer should be very brief. 0.99. What is the ratio of the Pupil-teacher ratio(headcount basis) of Argentina in 2003 to that in 2006?
Offer a terse response. 1.14. What is the ratio of the Pupil-teacher ratio(headcount basis) of Slovenia in 2003 to that in 2006?
Offer a very short reply. 1.29. What is the ratio of the Pupil-teacher ratio(headcount basis) of Latin America(all income levels) in 2004 to that in 2005?
Provide a succinct answer. 1.02. What is the ratio of the Pupil-teacher ratio(headcount basis) of Argentina in 2004 to that in 2005?
Your answer should be compact. 1.02. What is the ratio of the Pupil-teacher ratio(headcount basis) in Slovak Republic in 2004 to that in 2005?
Your answer should be compact. 0.98. What is the ratio of the Pupil-teacher ratio(headcount basis) in Slovenia in 2004 to that in 2005?
Offer a very short reply. 1.02. What is the ratio of the Pupil-teacher ratio(headcount basis) in Latin America(all income levels) in 2004 to that in 2006?
Your answer should be compact. 0.98. What is the ratio of the Pupil-teacher ratio(headcount basis) of Argentina in 2004 to that in 2006?
Offer a terse response. 1.08. What is the ratio of the Pupil-teacher ratio(headcount basis) of Slovak Republic in 2004 to that in 2006?
Keep it short and to the point. 1.01. What is the ratio of the Pupil-teacher ratio(headcount basis) of Slovenia in 2004 to that in 2006?
Offer a terse response. 1.07. What is the ratio of the Pupil-teacher ratio(headcount basis) in Argentina in 2005 to that in 2006?
Give a very brief answer. 1.06. What is the ratio of the Pupil-teacher ratio(headcount basis) of Slovak Republic in 2005 to that in 2006?
Offer a very short reply. 1.02. What is the ratio of the Pupil-teacher ratio(headcount basis) of Slovenia in 2005 to that in 2006?
Offer a very short reply. 1.05. What is the difference between the highest and the second highest Pupil-teacher ratio(headcount basis) in Latin America(all income levels)?
Your answer should be compact. 0.64. What is the difference between the highest and the second highest Pupil-teacher ratio(headcount basis) of Argentina?
Your answer should be compact. 0.35. What is the difference between the highest and the second highest Pupil-teacher ratio(headcount basis) of Slovak Republic?
Provide a succinct answer. 0.19. What is the difference between the highest and the second highest Pupil-teacher ratio(headcount basis) of Slovenia?
Provide a succinct answer. 0.59. What is the difference between the highest and the lowest Pupil-teacher ratio(headcount basis) in Latin America(all income levels)?
Your answer should be very brief. 2.3. What is the difference between the highest and the lowest Pupil-teacher ratio(headcount basis) in Argentina?
Keep it short and to the point. 2.88. What is the difference between the highest and the lowest Pupil-teacher ratio(headcount basis) of Slovak Republic?
Your answer should be compact. 0.46. What is the difference between the highest and the lowest Pupil-teacher ratio(headcount basis) of Slovenia?
Your answer should be very brief. 3.11. 